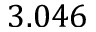Convert formula to latex. <formula><loc_0><loc_0><loc_500><loc_500>3 . 0 4 6</formula> 